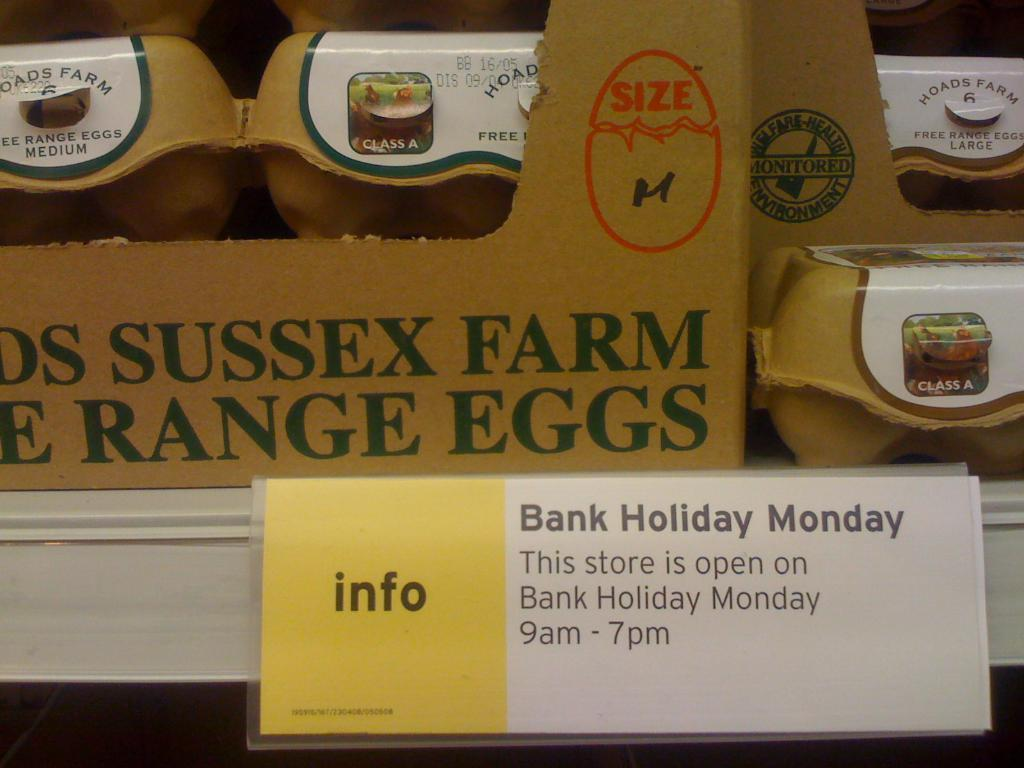What is contained within the box in the image? There are eggs in a box. Where is the box located in the image? The box is present in a rack. How is the rack positioned in the image? The rack is located above the ground. Is there any additional information provided on the rack? Yes, there is a name card present on the rack. What does the writer hope to achieve with the mind in the image? There is no writer, mind, or hope present in the image; it only features a box of eggs in a rack with a name card. 